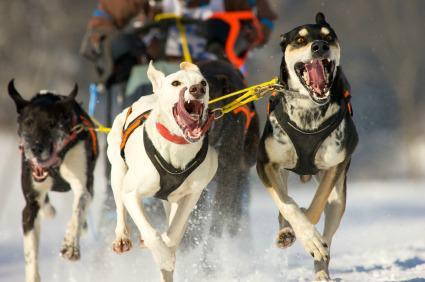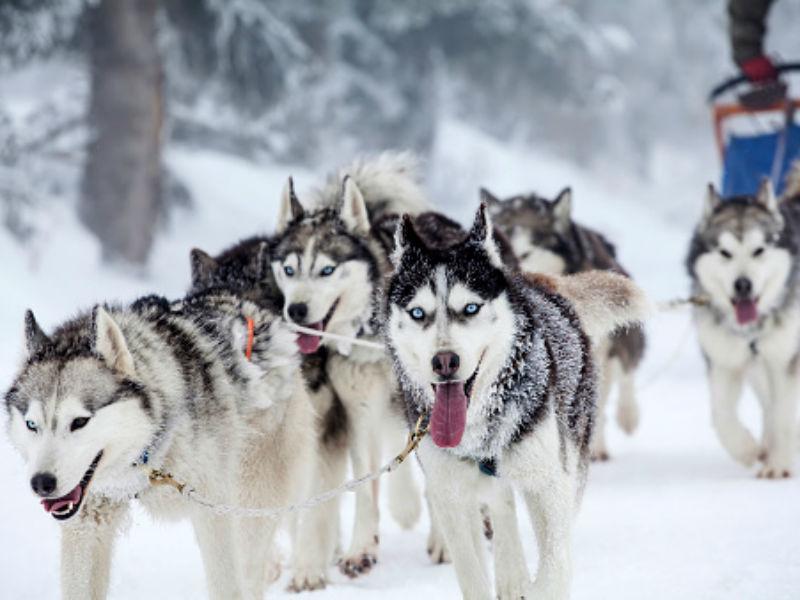The first image is the image on the left, the second image is the image on the right. Considering the images on both sides, is "A team of dogs is heading down a path lined with snow-covered trees." valid? Answer yes or no. No. The first image is the image on the left, the second image is the image on the right. For the images displayed, is the sentence "At least one lead dog clearly has their tongue hanging out." factually correct? Answer yes or no. Yes. 